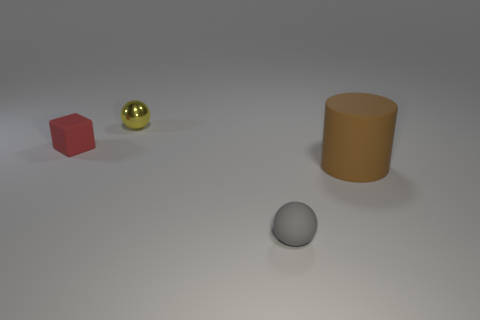Is there any other thing that is the same size as the brown matte cylinder?
Your answer should be very brief. No. There is a tiny thing that is right of the tiny red matte thing and in front of the tiny yellow metal object; what is its shape?
Your response must be concise. Sphere. What color is the block that is the same size as the shiny sphere?
Offer a terse response. Red. There is a matte object left of the small matte sphere; is it the same size as the ball in front of the red thing?
Make the answer very short. Yes. How big is the thing that is in front of the thing on the right side of the ball in front of the small red thing?
Your response must be concise. Small. The small rubber thing right of the ball that is behind the small gray thing is what shape?
Ensure brevity in your answer.  Sphere. There is a ball that is behind the large brown rubber cylinder; does it have the same color as the matte sphere?
Give a very brief answer. No. What is the color of the thing that is both in front of the yellow metallic object and behind the brown cylinder?
Provide a succinct answer. Red. Are there any other yellow balls made of the same material as the tiny yellow sphere?
Keep it short and to the point. No. What is the size of the yellow metal thing?
Offer a terse response. Small. 